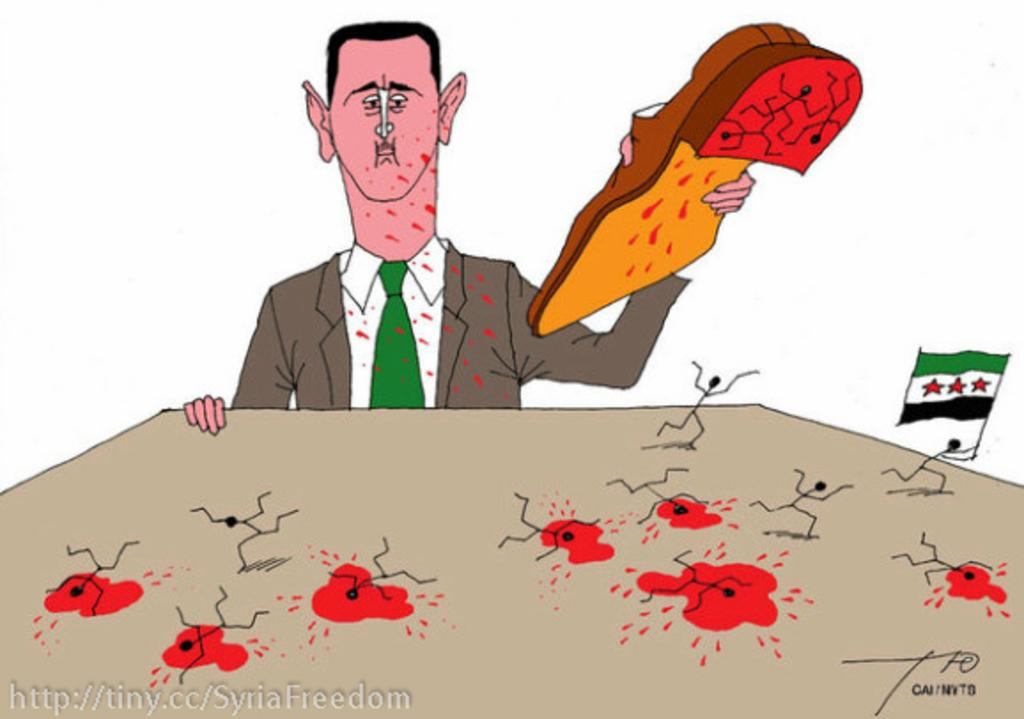What type of artwork is depicted in the image? The image is a painting. What is the person in the painting holding? The person is holding a shoe in the painting. Where is the person located in the painting? The person is at a table in the painting. What can be seen on the table in the painting? There is blood visible on the table, as well as a flag. Are there any other people present in the painting? Yes, there are other persons present in the painting. What is written or depicted at the bottom of the painting? There is text at the bottom of the painting. How many birds are sitting on the person's shoulder in the painting? There are no birds present in the painting. What type of squirrel can be seen climbing the flagpole in the painting? There is no squirrel present in the painting. 